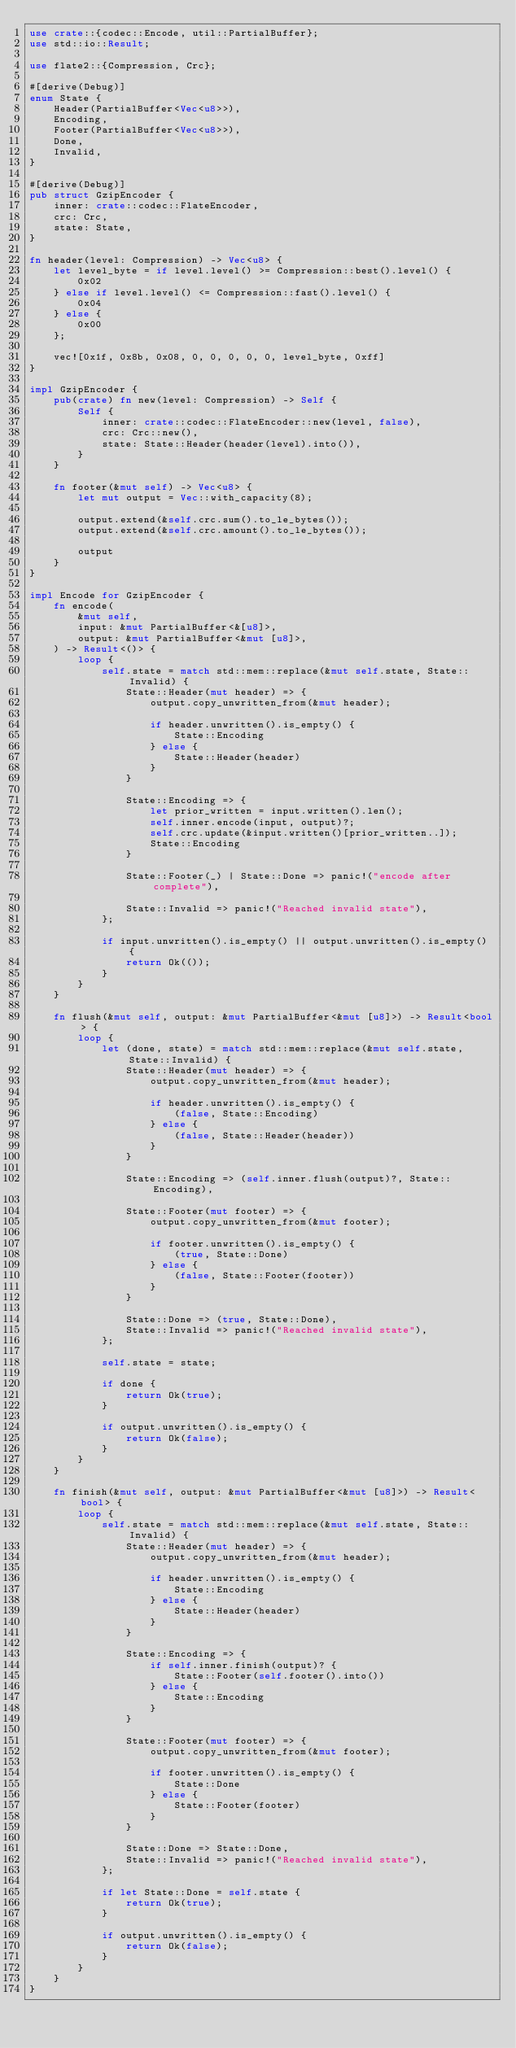Convert code to text. <code><loc_0><loc_0><loc_500><loc_500><_Rust_>use crate::{codec::Encode, util::PartialBuffer};
use std::io::Result;

use flate2::{Compression, Crc};

#[derive(Debug)]
enum State {
    Header(PartialBuffer<Vec<u8>>),
    Encoding,
    Footer(PartialBuffer<Vec<u8>>),
    Done,
    Invalid,
}

#[derive(Debug)]
pub struct GzipEncoder {
    inner: crate::codec::FlateEncoder,
    crc: Crc,
    state: State,
}

fn header(level: Compression) -> Vec<u8> {
    let level_byte = if level.level() >= Compression::best().level() {
        0x02
    } else if level.level() <= Compression::fast().level() {
        0x04
    } else {
        0x00
    };

    vec![0x1f, 0x8b, 0x08, 0, 0, 0, 0, 0, level_byte, 0xff]
}

impl GzipEncoder {
    pub(crate) fn new(level: Compression) -> Self {
        Self {
            inner: crate::codec::FlateEncoder::new(level, false),
            crc: Crc::new(),
            state: State::Header(header(level).into()),
        }
    }

    fn footer(&mut self) -> Vec<u8> {
        let mut output = Vec::with_capacity(8);

        output.extend(&self.crc.sum().to_le_bytes());
        output.extend(&self.crc.amount().to_le_bytes());

        output
    }
}

impl Encode for GzipEncoder {
    fn encode(
        &mut self,
        input: &mut PartialBuffer<&[u8]>,
        output: &mut PartialBuffer<&mut [u8]>,
    ) -> Result<()> {
        loop {
            self.state = match std::mem::replace(&mut self.state, State::Invalid) {
                State::Header(mut header) => {
                    output.copy_unwritten_from(&mut header);

                    if header.unwritten().is_empty() {
                        State::Encoding
                    } else {
                        State::Header(header)
                    }
                }

                State::Encoding => {
                    let prior_written = input.written().len();
                    self.inner.encode(input, output)?;
                    self.crc.update(&input.written()[prior_written..]);
                    State::Encoding
                }

                State::Footer(_) | State::Done => panic!("encode after complete"),

                State::Invalid => panic!("Reached invalid state"),
            };

            if input.unwritten().is_empty() || output.unwritten().is_empty() {
                return Ok(());
            }
        }
    }

    fn flush(&mut self, output: &mut PartialBuffer<&mut [u8]>) -> Result<bool> {
        loop {
            let (done, state) = match std::mem::replace(&mut self.state, State::Invalid) {
                State::Header(mut header) => {
                    output.copy_unwritten_from(&mut header);

                    if header.unwritten().is_empty() {
                        (false, State::Encoding)
                    } else {
                        (false, State::Header(header))
                    }
                }

                State::Encoding => (self.inner.flush(output)?, State::Encoding),

                State::Footer(mut footer) => {
                    output.copy_unwritten_from(&mut footer);

                    if footer.unwritten().is_empty() {
                        (true, State::Done)
                    } else {
                        (false, State::Footer(footer))
                    }
                }

                State::Done => (true, State::Done),
                State::Invalid => panic!("Reached invalid state"),
            };

            self.state = state;

            if done {
                return Ok(true);
            }

            if output.unwritten().is_empty() {
                return Ok(false);
            }
        }
    }

    fn finish(&mut self, output: &mut PartialBuffer<&mut [u8]>) -> Result<bool> {
        loop {
            self.state = match std::mem::replace(&mut self.state, State::Invalid) {
                State::Header(mut header) => {
                    output.copy_unwritten_from(&mut header);

                    if header.unwritten().is_empty() {
                        State::Encoding
                    } else {
                        State::Header(header)
                    }
                }

                State::Encoding => {
                    if self.inner.finish(output)? {
                        State::Footer(self.footer().into())
                    } else {
                        State::Encoding
                    }
                }

                State::Footer(mut footer) => {
                    output.copy_unwritten_from(&mut footer);

                    if footer.unwritten().is_empty() {
                        State::Done
                    } else {
                        State::Footer(footer)
                    }
                }

                State::Done => State::Done,
                State::Invalid => panic!("Reached invalid state"),
            };

            if let State::Done = self.state {
                return Ok(true);
            }

            if output.unwritten().is_empty() {
                return Ok(false);
            }
        }
    }
}
</code> 